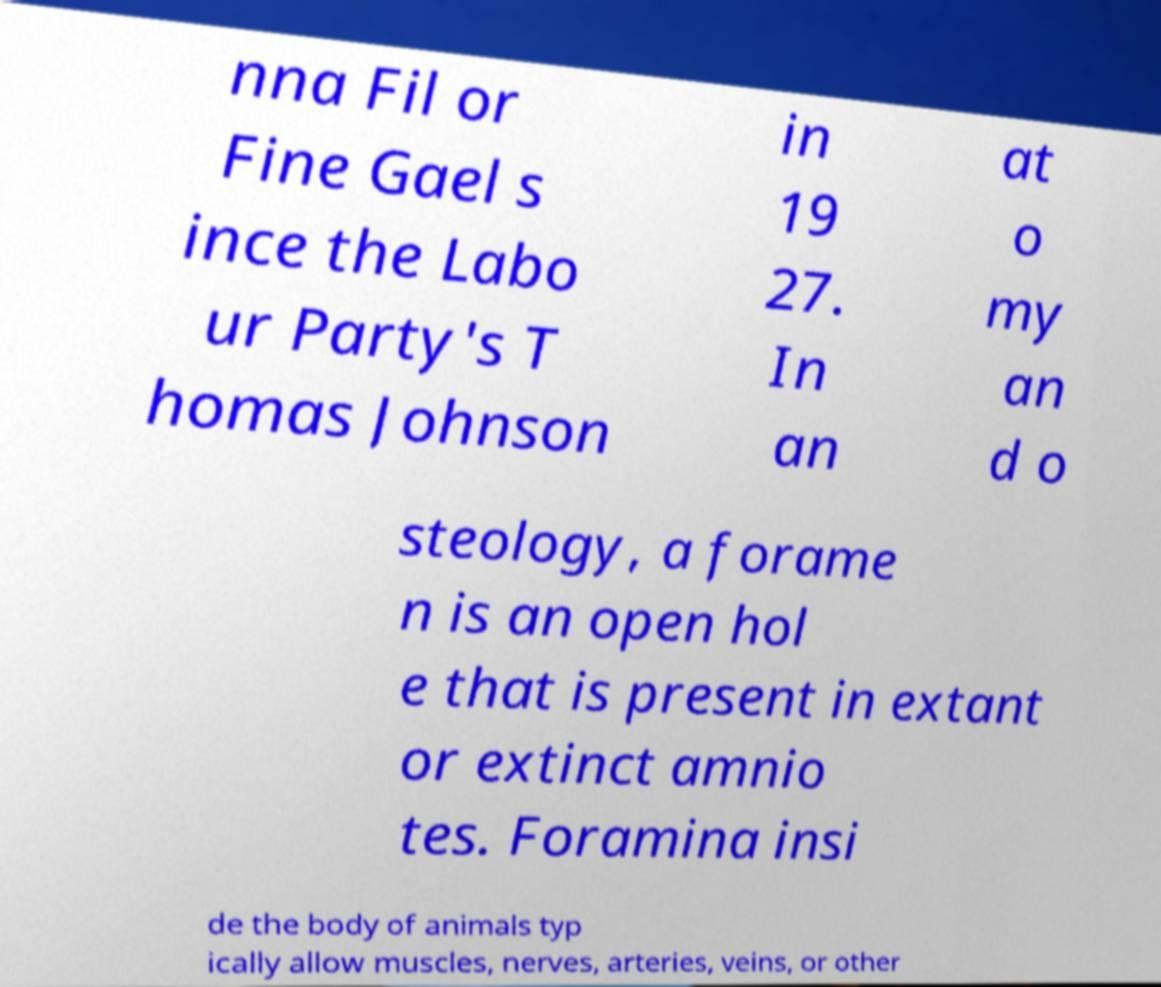Can you read and provide the text displayed in the image?This photo seems to have some interesting text. Can you extract and type it out for me? nna Fil or Fine Gael s ince the Labo ur Party's T homas Johnson in 19 27. In an at o my an d o steology, a forame n is an open hol e that is present in extant or extinct amnio tes. Foramina insi de the body of animals typ ically allow muscles, nerves, arteries, veins, or other 